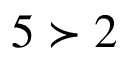<formula> <loc_0><loc_0><loc_500><loc_500>5 \succ 2</formula> 